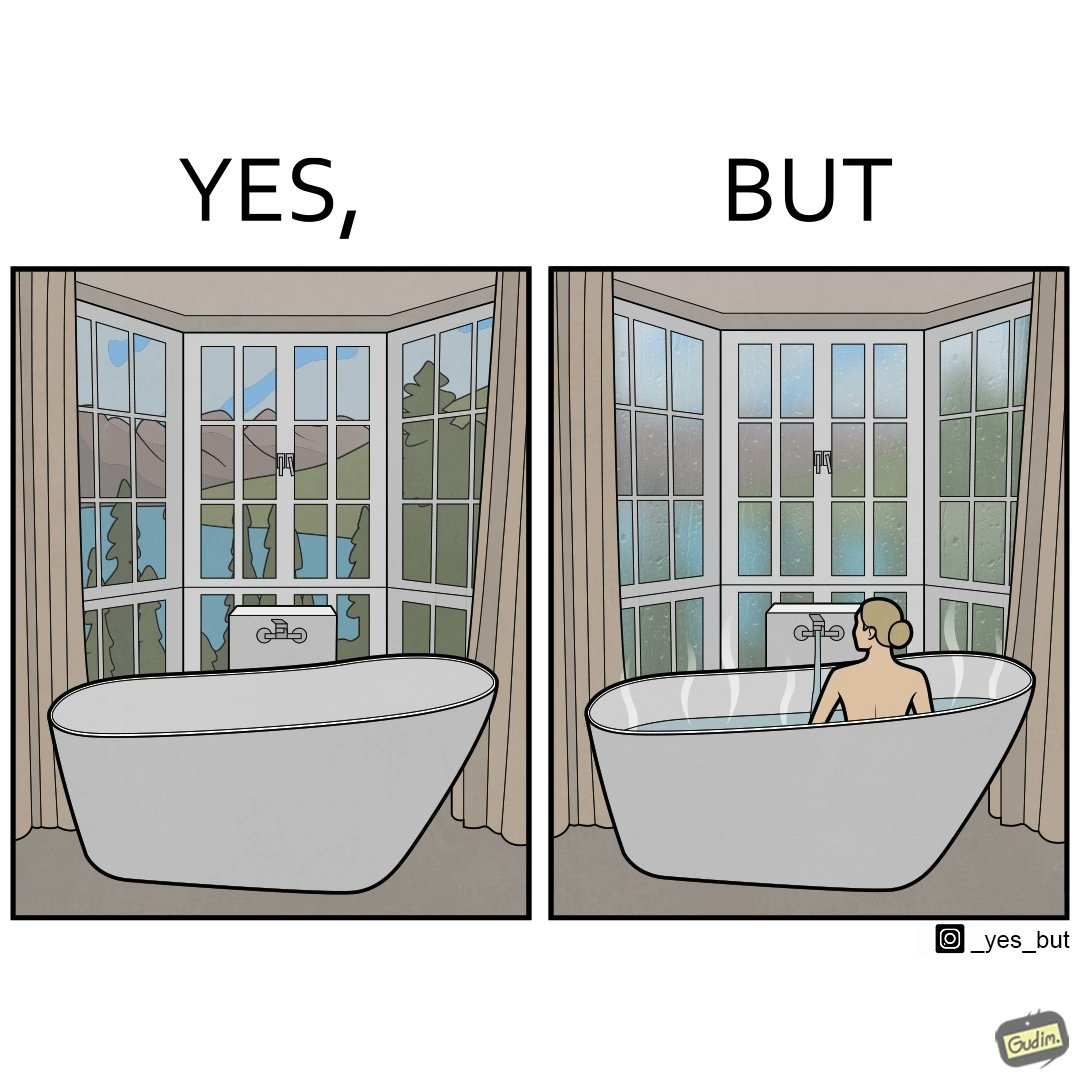What is shown in this image? The image is ironical, as a bathtub near a window having a very scenic view, becomes misty when someone is bathing, thus making the scenic view blurry. 